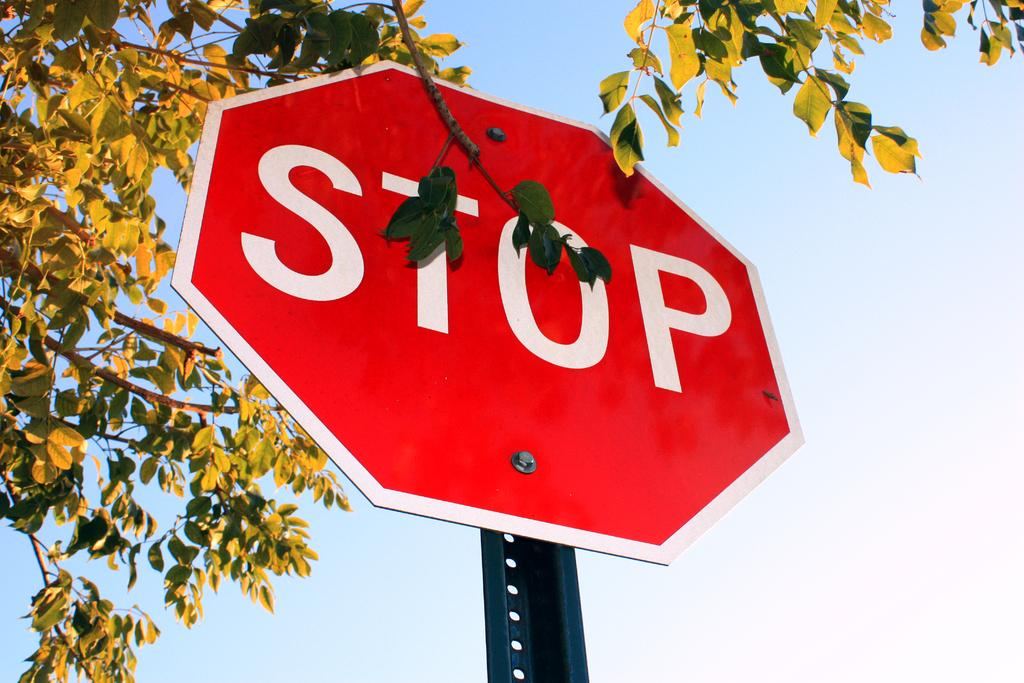<image>
Provide a brief description of the given image. A red octagonal sign says "stop" on it. 